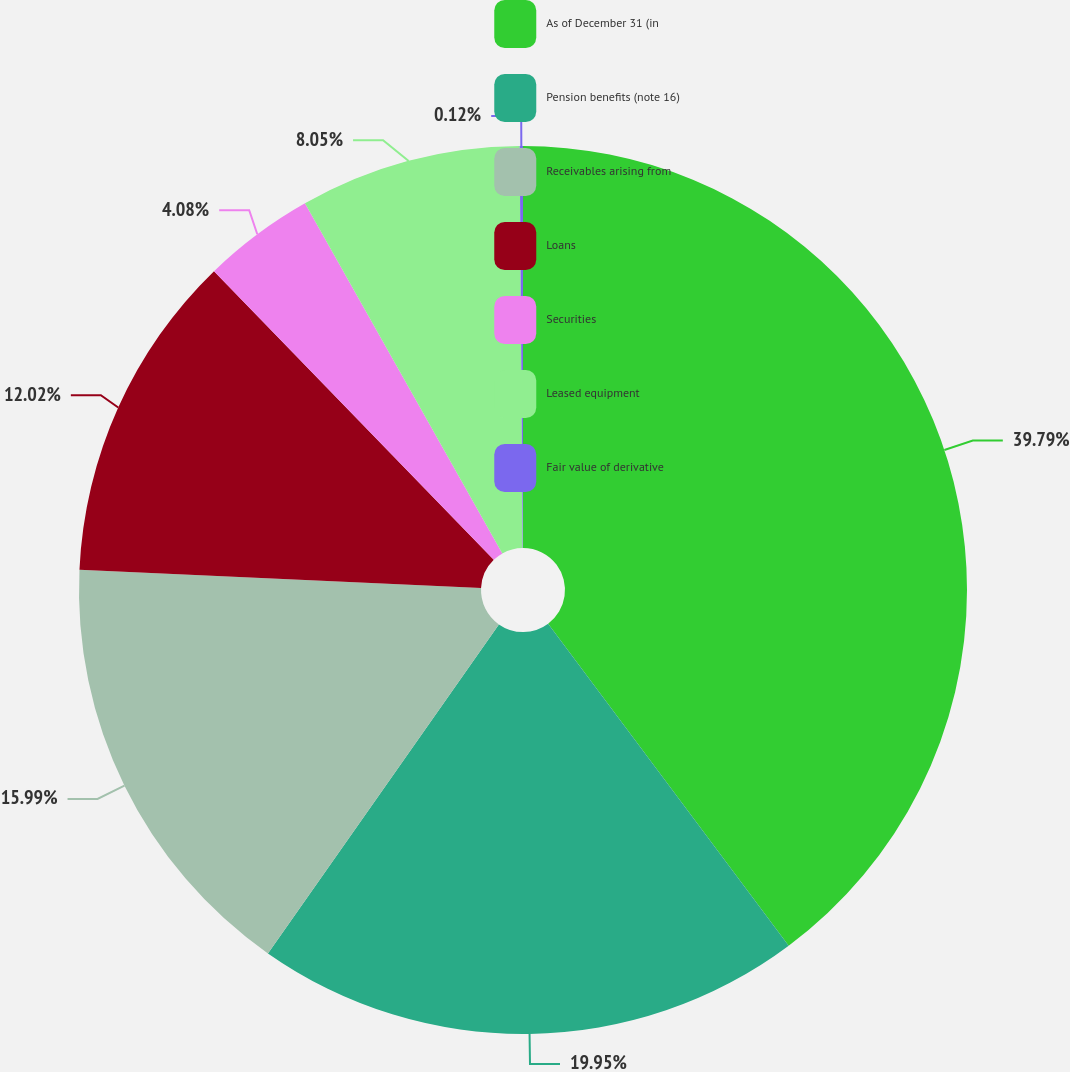<chart> <loc_0><loc_0><loc_500><loc_500><pie_chart><fcel>As of December 31 (in<fcel>Pension benefits (note 16)<fcel>Receivables arising from<fcel>Loans<fcel>Securities<fcel>Leased equipment<fcel>Fair value of derivative<nl><fcel>39.79%<fcel>19.95%<fcel>15.99%<fcel>12.02%<fcel>4.08%<fcel>8.05%<fcel>0.12%<nl></chart> 